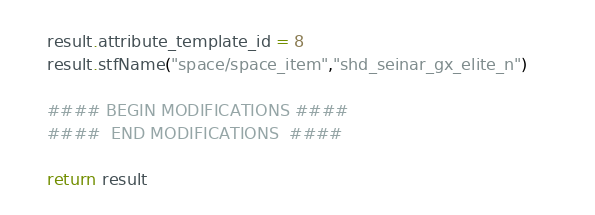<code> <loc_0><loc_0><loc_500><loc_500><_Python_>	result.attribute_template_id = 8
	result.stfName("space/space_item","shd_seinar_gx_elite_n")		
	
	#### BEGIN MODIFICATIONS ####
	####  END MODIFICATIONS  ####
	
	return result</code> 